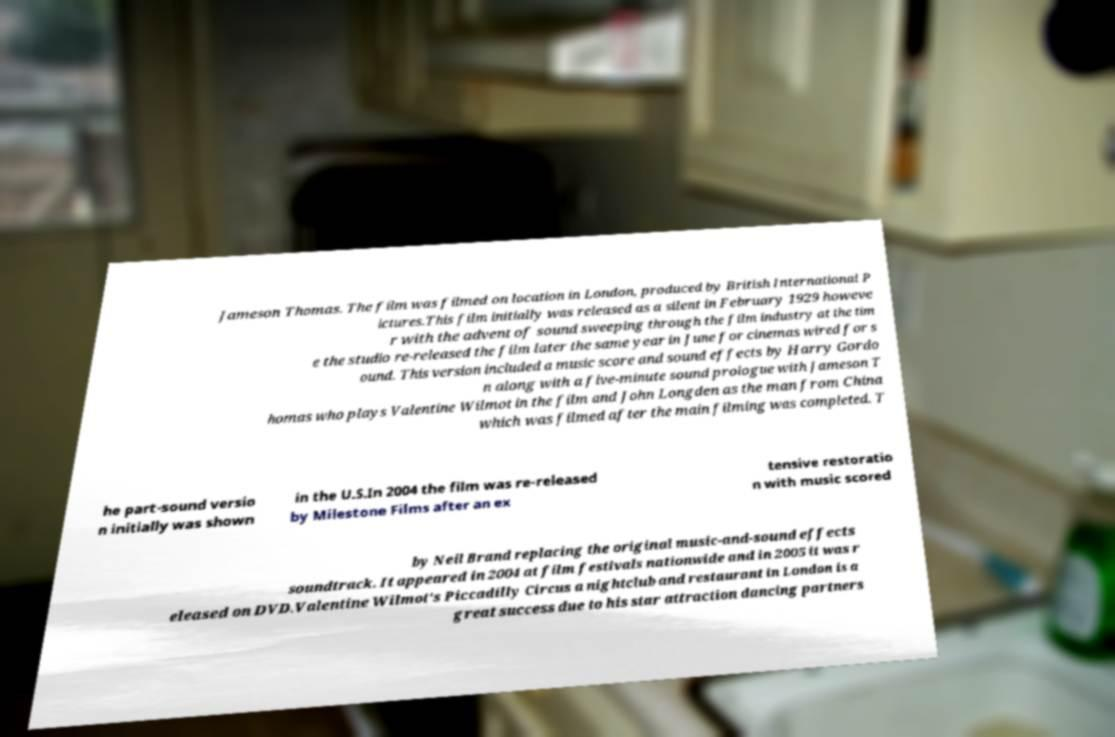For documentation purposes, I need the text within this image transcribed. Could you provide that? Jameson Thomas. The film was filmed on location in London, produced by British International P ictures.This film initially was released as a silent in February 1929 howeve r with the advent of sound sweeping through the film industry at the tim e the studio re-released the film later the same year in June for cinemas wired for s ound. This version included a music score and sound effects by Harry Gordo n along with a five-minute sound prologue with Jameson T homas who plays Valentine Wilmot in the film and John Longden as the man from China which was filmed after the main filming was completed. T he part-sound versio n initially was shown in the U.S.In 2004 the film was re-released by Milestone Films after an ex tensive restoratio n with music scored by Neil Brand replacing the original music-and-sound effects soundtrack. It appeared in 2004 at film festivals nationwide and in 2005 it was r eleased on DVD.Valentine Wilmot's Piccadilly Circus a nightclub and restaurant in London is a great success due to his star attraction dancing partners 